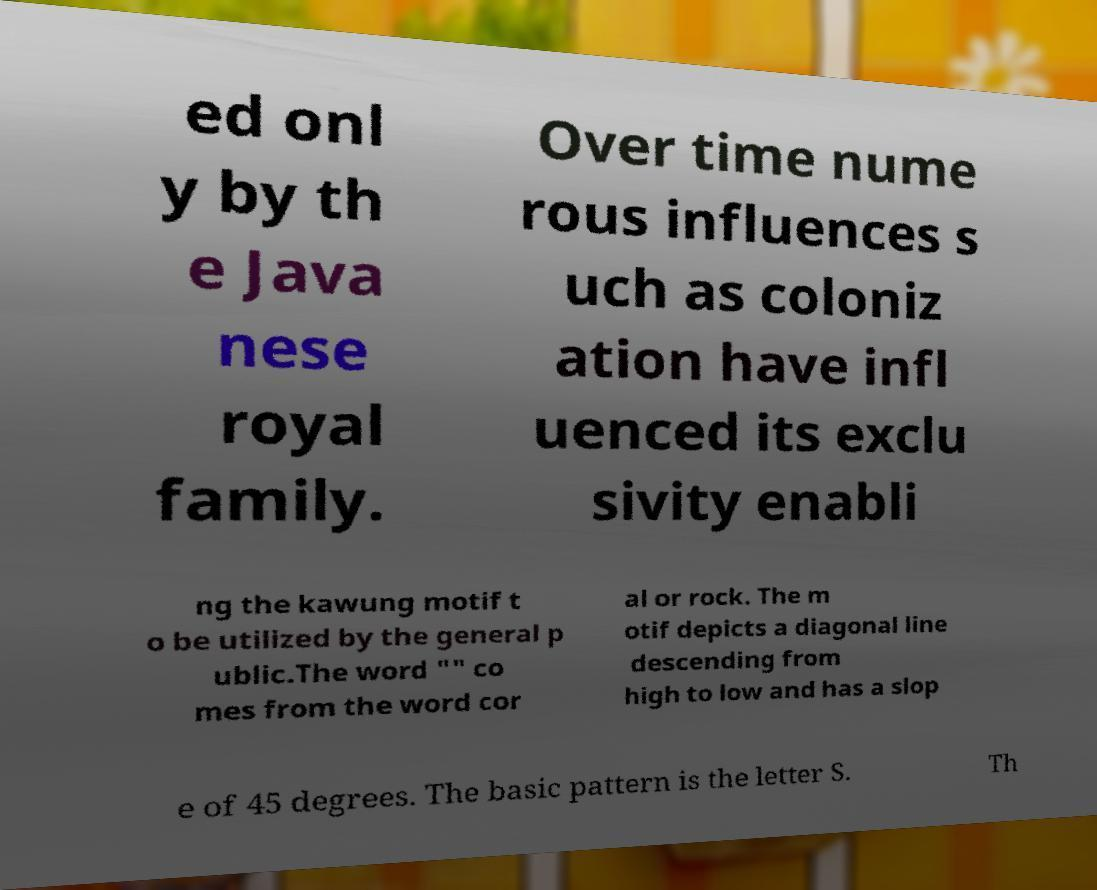Please identify and transcribe the text found in this image. ed onl y by th e Java nese royal family. Over time nume rous influences s uch as coloniz ation have infl uenced its exclu sivity enabli ng the kawung motif t o be utilized by the general p ublic.The word "" co mes from the word cor al or rock. The m otif depicts a diagonal line descending from high to low and has a slop e of 45 degrees. The basic pattern is the letter S. Th 